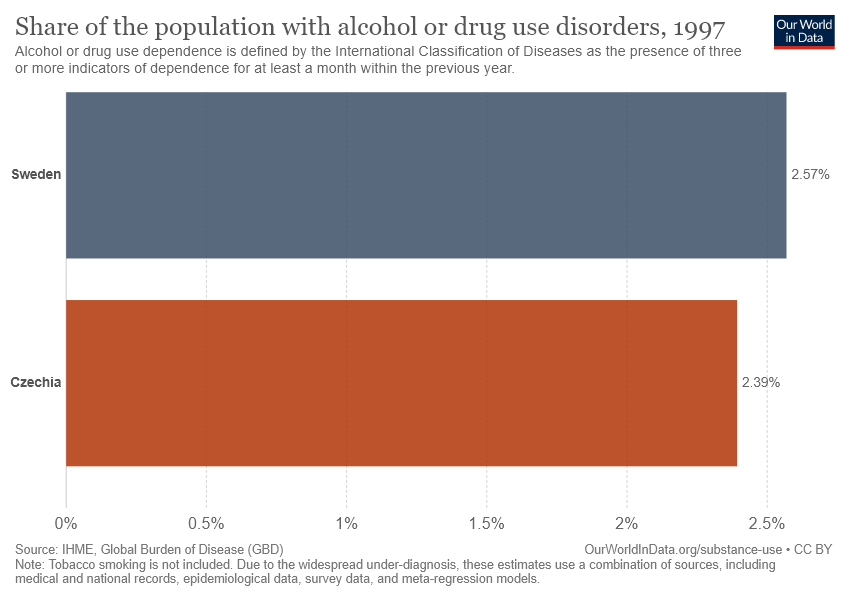Specify some key components in this picture. The alcohol and drug use rate is 0.18 higher in Sweden compared to Czechia. The place in Sweden has a higher share of the population with alcohol or drug use disorders compared to the place in Czechia. 